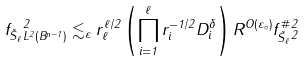Convert formula to latex. <formula><loc_0><loc_0><loc_500><loc_500>\| f _ { \vec { S } _ { \ell } } \| _ { L ^ { 2 } ( B ^ { n - 1 } ) } ^ { 2 } \lesssim _ { \varepsilon } r _ { \ell } ^ { \ell / 2 } \left ( \prod _ { i = 1 } ^ { \ell } r _ { i } ^ { - 1 / 2 } D _ { i } ^ { \delta } \right ) R ^ { O ( \varepsilon _ { \circ } ) } \| f _ { \vec { S } _ { \ell } } ^ { \# } \| _ { 2 } ^ { 2 }</formula> 